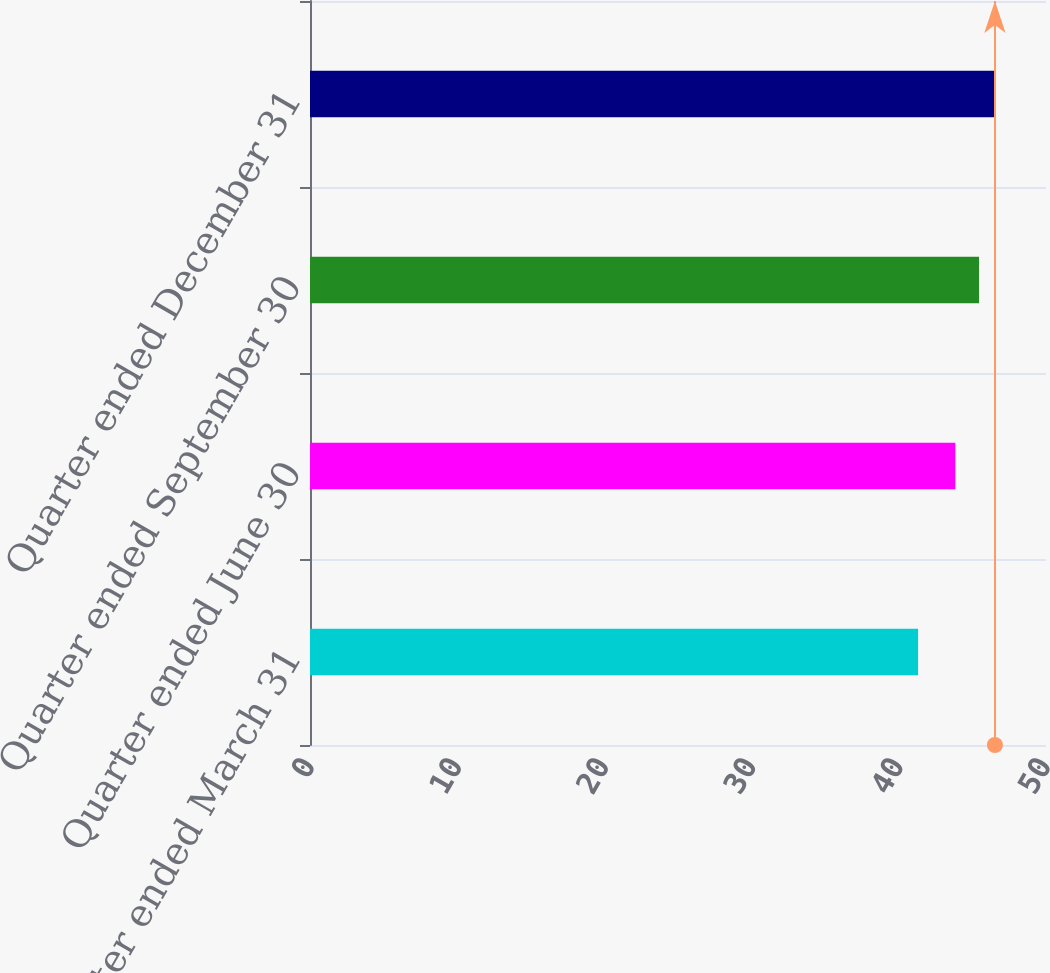Convert chart to OTSL. <chart><loc_0><loc_0><loc_500><loc_500><bar_chart><fcel>Quarter ended March 31<fcel>Quarter ended June 30<fcel>Quarter ended September 30<fcel>Quarter ended December 31<nl><fcel>41.31<fcel>43.84<fcel>45.45<fcel>46.53<nl></chart> 